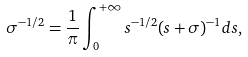Convert formula to latex. <formula><loc_0><loc_0><loc_500><loc_500>\sigma ^ { - 1 / 2 } = \frac { 1 } { \pi } \int _ { 0 } ^ { + \infty } s ^ { - 1 / 2 } ( s + \sigma ) ^ { - 1 } d s ,</formula> 